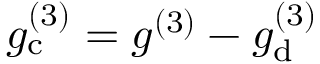Convert formula to latex. <formula><loc_0><loc_0><loc_500><loc_500>g _ { c } ^ { ( 3 ) } = g ^ { ( 3 ) } - g _ { d } ^ { ( 3 ) }</formula> 